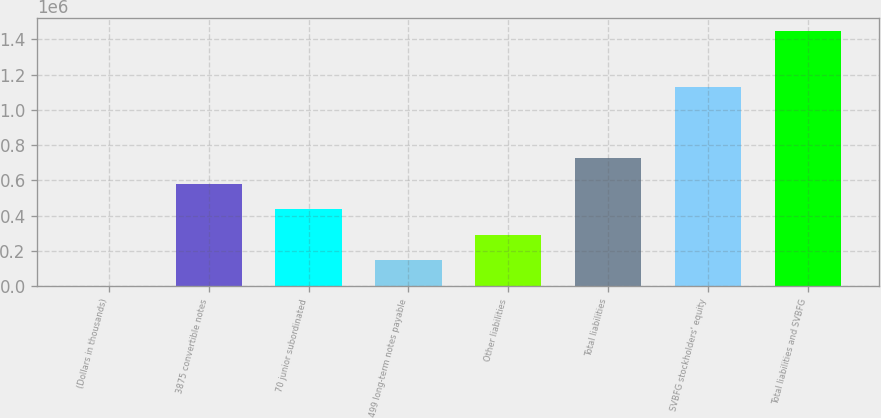Convert chart to OTSL. <chart><loc_0><loc_0><loc_500><loc_500><bar_chart><fcel>(Dollars in thousands)<fcel>3875 convertible notes<fcel>70 junior subordinated<fcel>499 long-term notes payable<fcel>Other liabilities<fcel>Total liabilities<fcel>SVBFG stockholders' equity<fcel>Total liabilities and SVBFG<nl><fcel>2009<fcel>579850<fcel>435390<fcel>146469<fcel>290929<fcel>724310<fcel>1.12834e+06<fcel>1.44661e+06<nl></chart> 